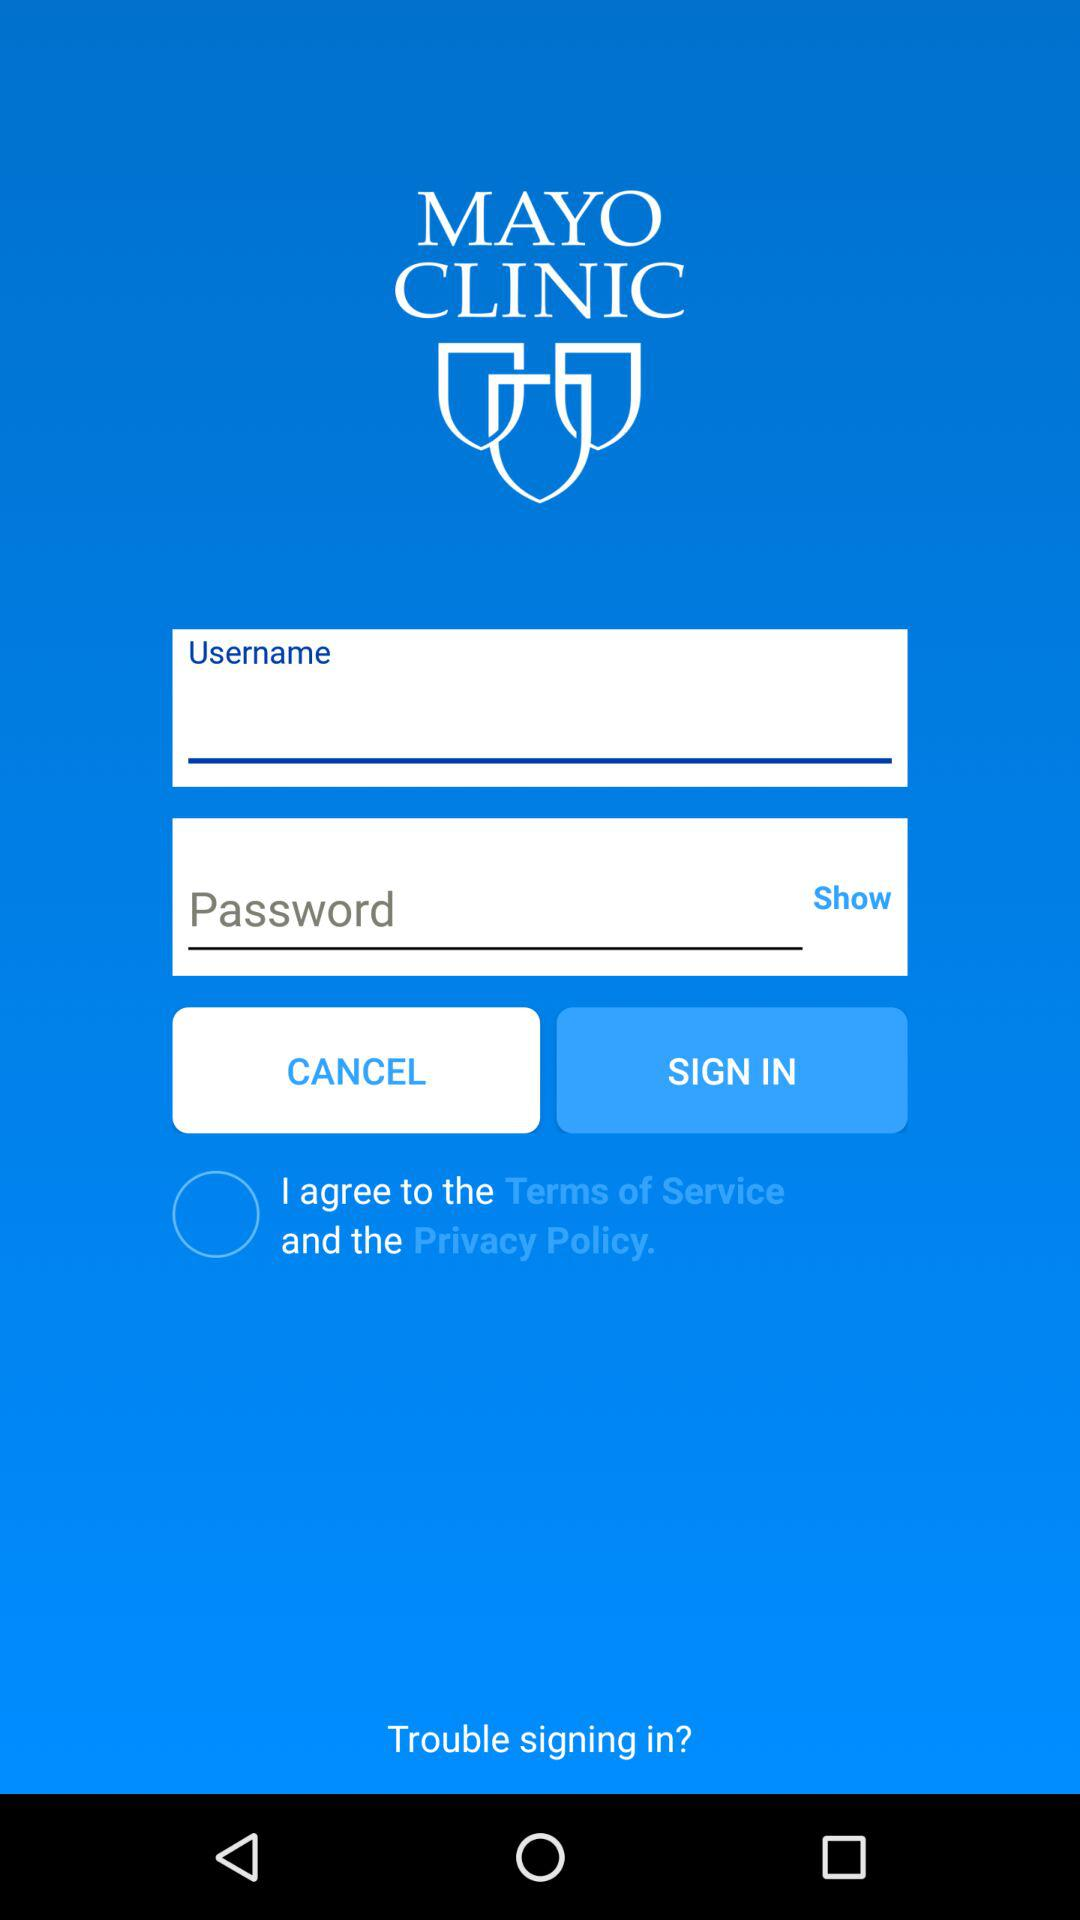What is the application name? The application name is "Mayo Clinic". 